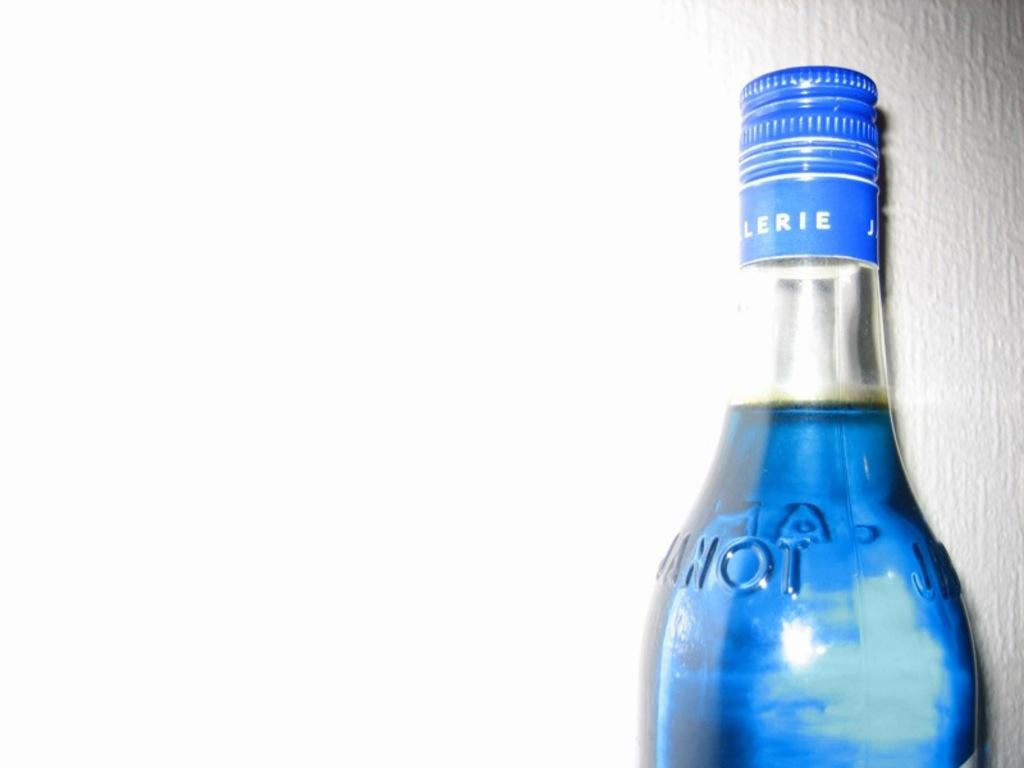What object is present in the image that contains a liquid? There is a bottle in the image that contains a liquid. What color is the liquid inside the bottle? The liquid inside the bottle is blue. Where is the bottle located in relation to other objects or structures in the image? The bottle is placed near a wall. What type of vest is being worn by the person holding the bottle in the image? There is no person holding the bottle in the image, and therefore no vest can be observed. 